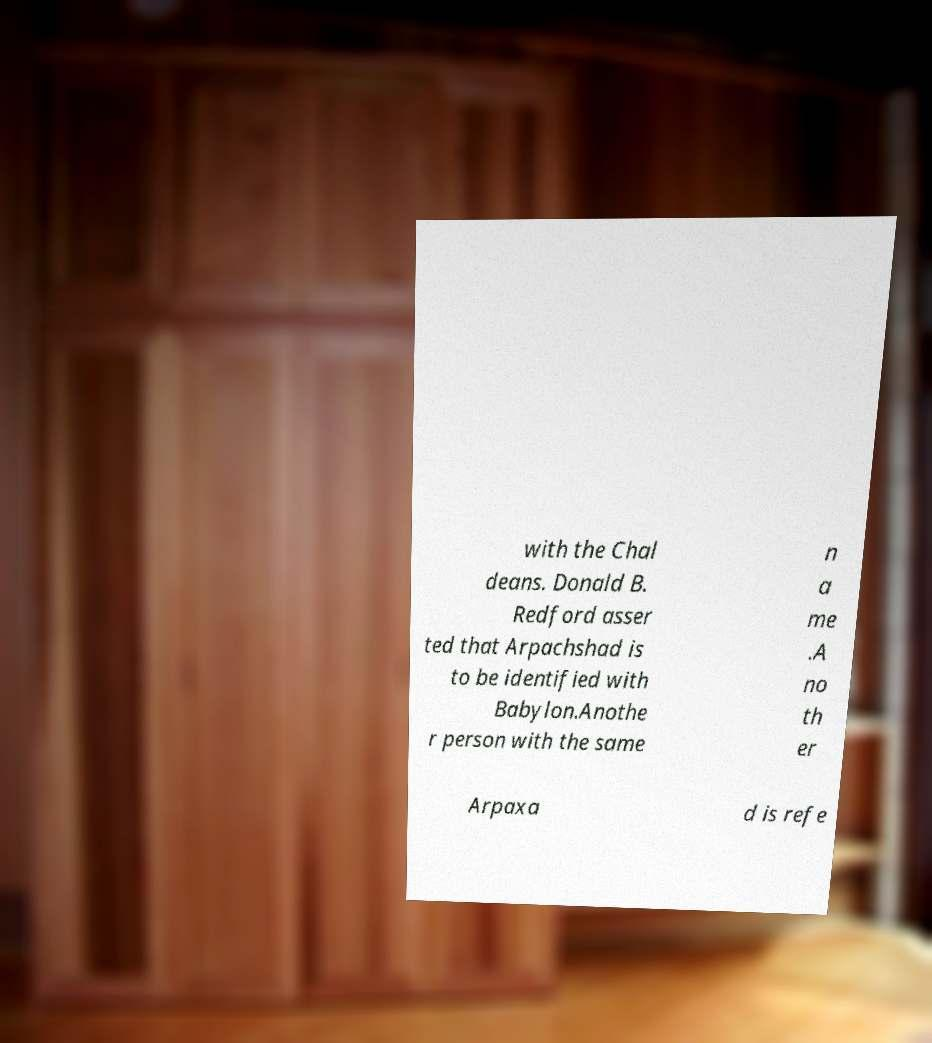For documentation purposes, I need the text within this image transcribed. Could you provide that? with the Chal deans. Donald B. Redford asser ted that Arpachshad is to be identified with Babylon.Anothe r person with the same n a me .A no th er Arpaxa d is refe 